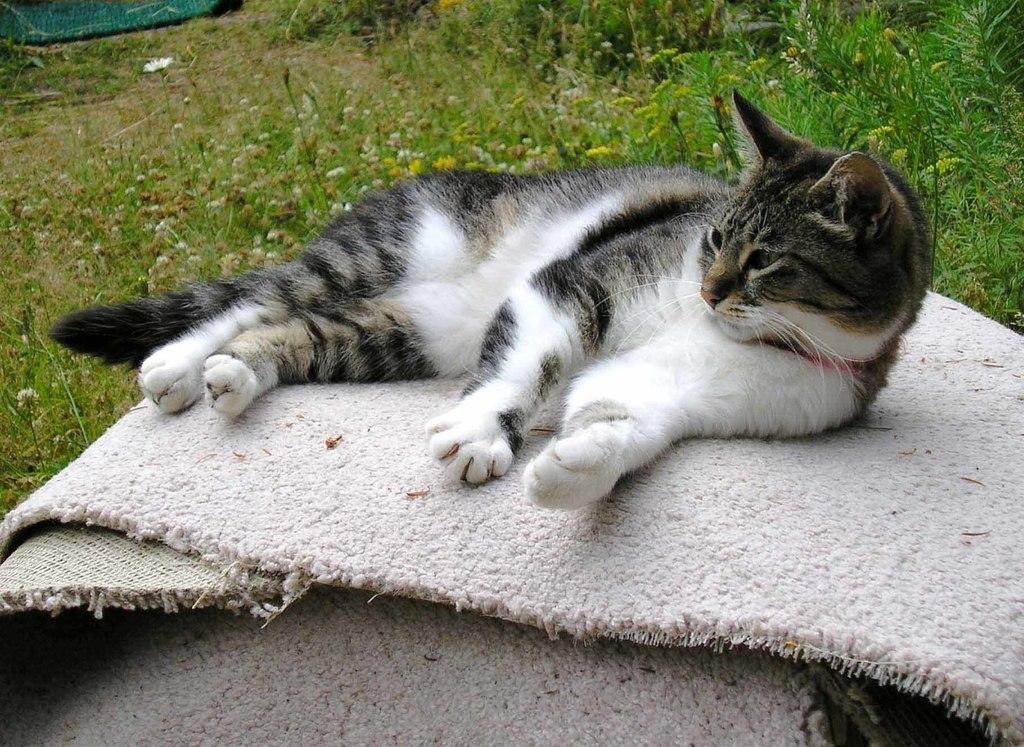What animal is lying on the door mat in the image? There is a cat lying on a door mat in the image. Where is the cat positioned in the image? The cat is in the middle of the image. What type of surface is visible in the background of the image? There is a grassy land in the background of the image. What type of fictional meeting is taking place in the image? There is no meeting, fictional or otherwise, depicted in the image. The image only shows a cat lying on a door mat with a grassy land in the background. 